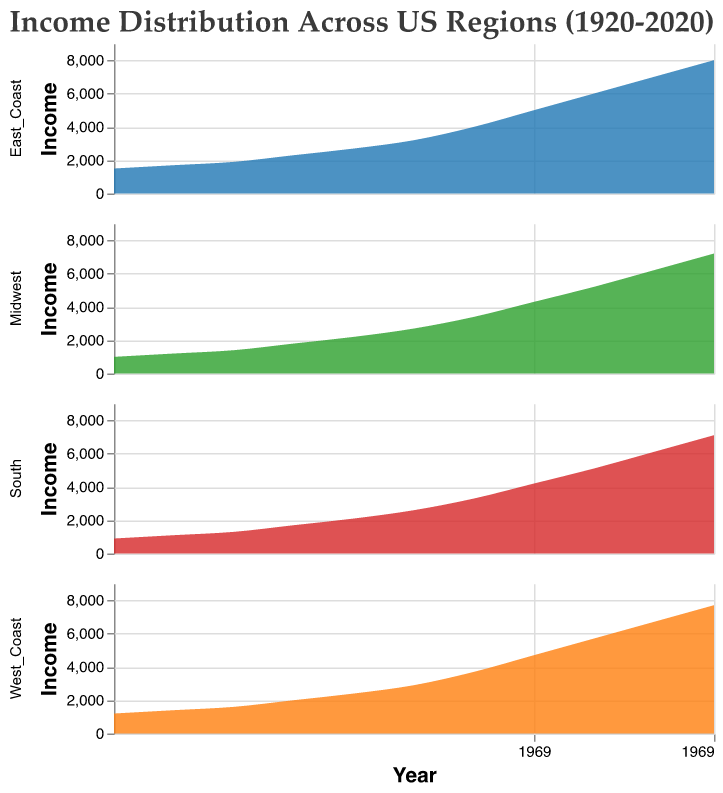What is the title of the figure? The title is usually displayed at the top of the figure. It provides a brief description of what the figure represents. In this case, the title is "Income Distribution Across US Regions (1920-2020)."
Answer: "Income Distribution Across US Regions (1920-2020)" Which region has the highest income in 2020? To find which region has the highest income in 2020, you need to look at the income values for that year and compare them across all regions. The East Coast has an income of 8000, which is the highest compared to the Midwest (7200), South (7100), and West Coast (7700).
Answer: East Coast How has the income trend for the Midwest region changed from 1920 to 2020? To understand the income trend for the Midwest, observe the line for the Midwest from 1920 through 2020. The income started at 1000 in 1920 and shows a steady increase over the decades, reaching 7200 by 2020.
Answer: Steadily increased Which region showed the least income growth between 1920 and 1930? To determine which region had the least growth, compare the income differences between 1920 and 1930 for each region. The East Coast grew from 1500 to 1700 (+200), the West Coast from 1200 to 1400 (+200), the Midwest from 1000 to 1200 (+200), and the South from 900 to 1100 (+200). All regions had equal growth.
Answer: All regions (equal growth) What was the income of the South region in the year 1970? Locate the point on the South region's line that corresponds to the year 1970. The income value for the South region in 1970 is 2600.
Answer: 2600 Between 1980 and 2000, which region saw the greatest increase in income? Calculate the difference in income for each region between 1980 and 2000. For the East Coast (6000-4000=2000), West Coast (5700-3700=2000), Midwest (5200-3400=1800), and South (5100-3300=1800). Both the East Coast and West Coast saw an increase of 2000, which is the greatest among all regions.
Answer: East Coast and West Coast What is the overall trend in income distribution across all regions from 1920 to 2020? To identify the overall trend, observe the general direction of the lines for all regions from 1920 to 2020. All regions show an upward trend, meaning there is an overall rise in income over the past century.
Answer: Rising trend 